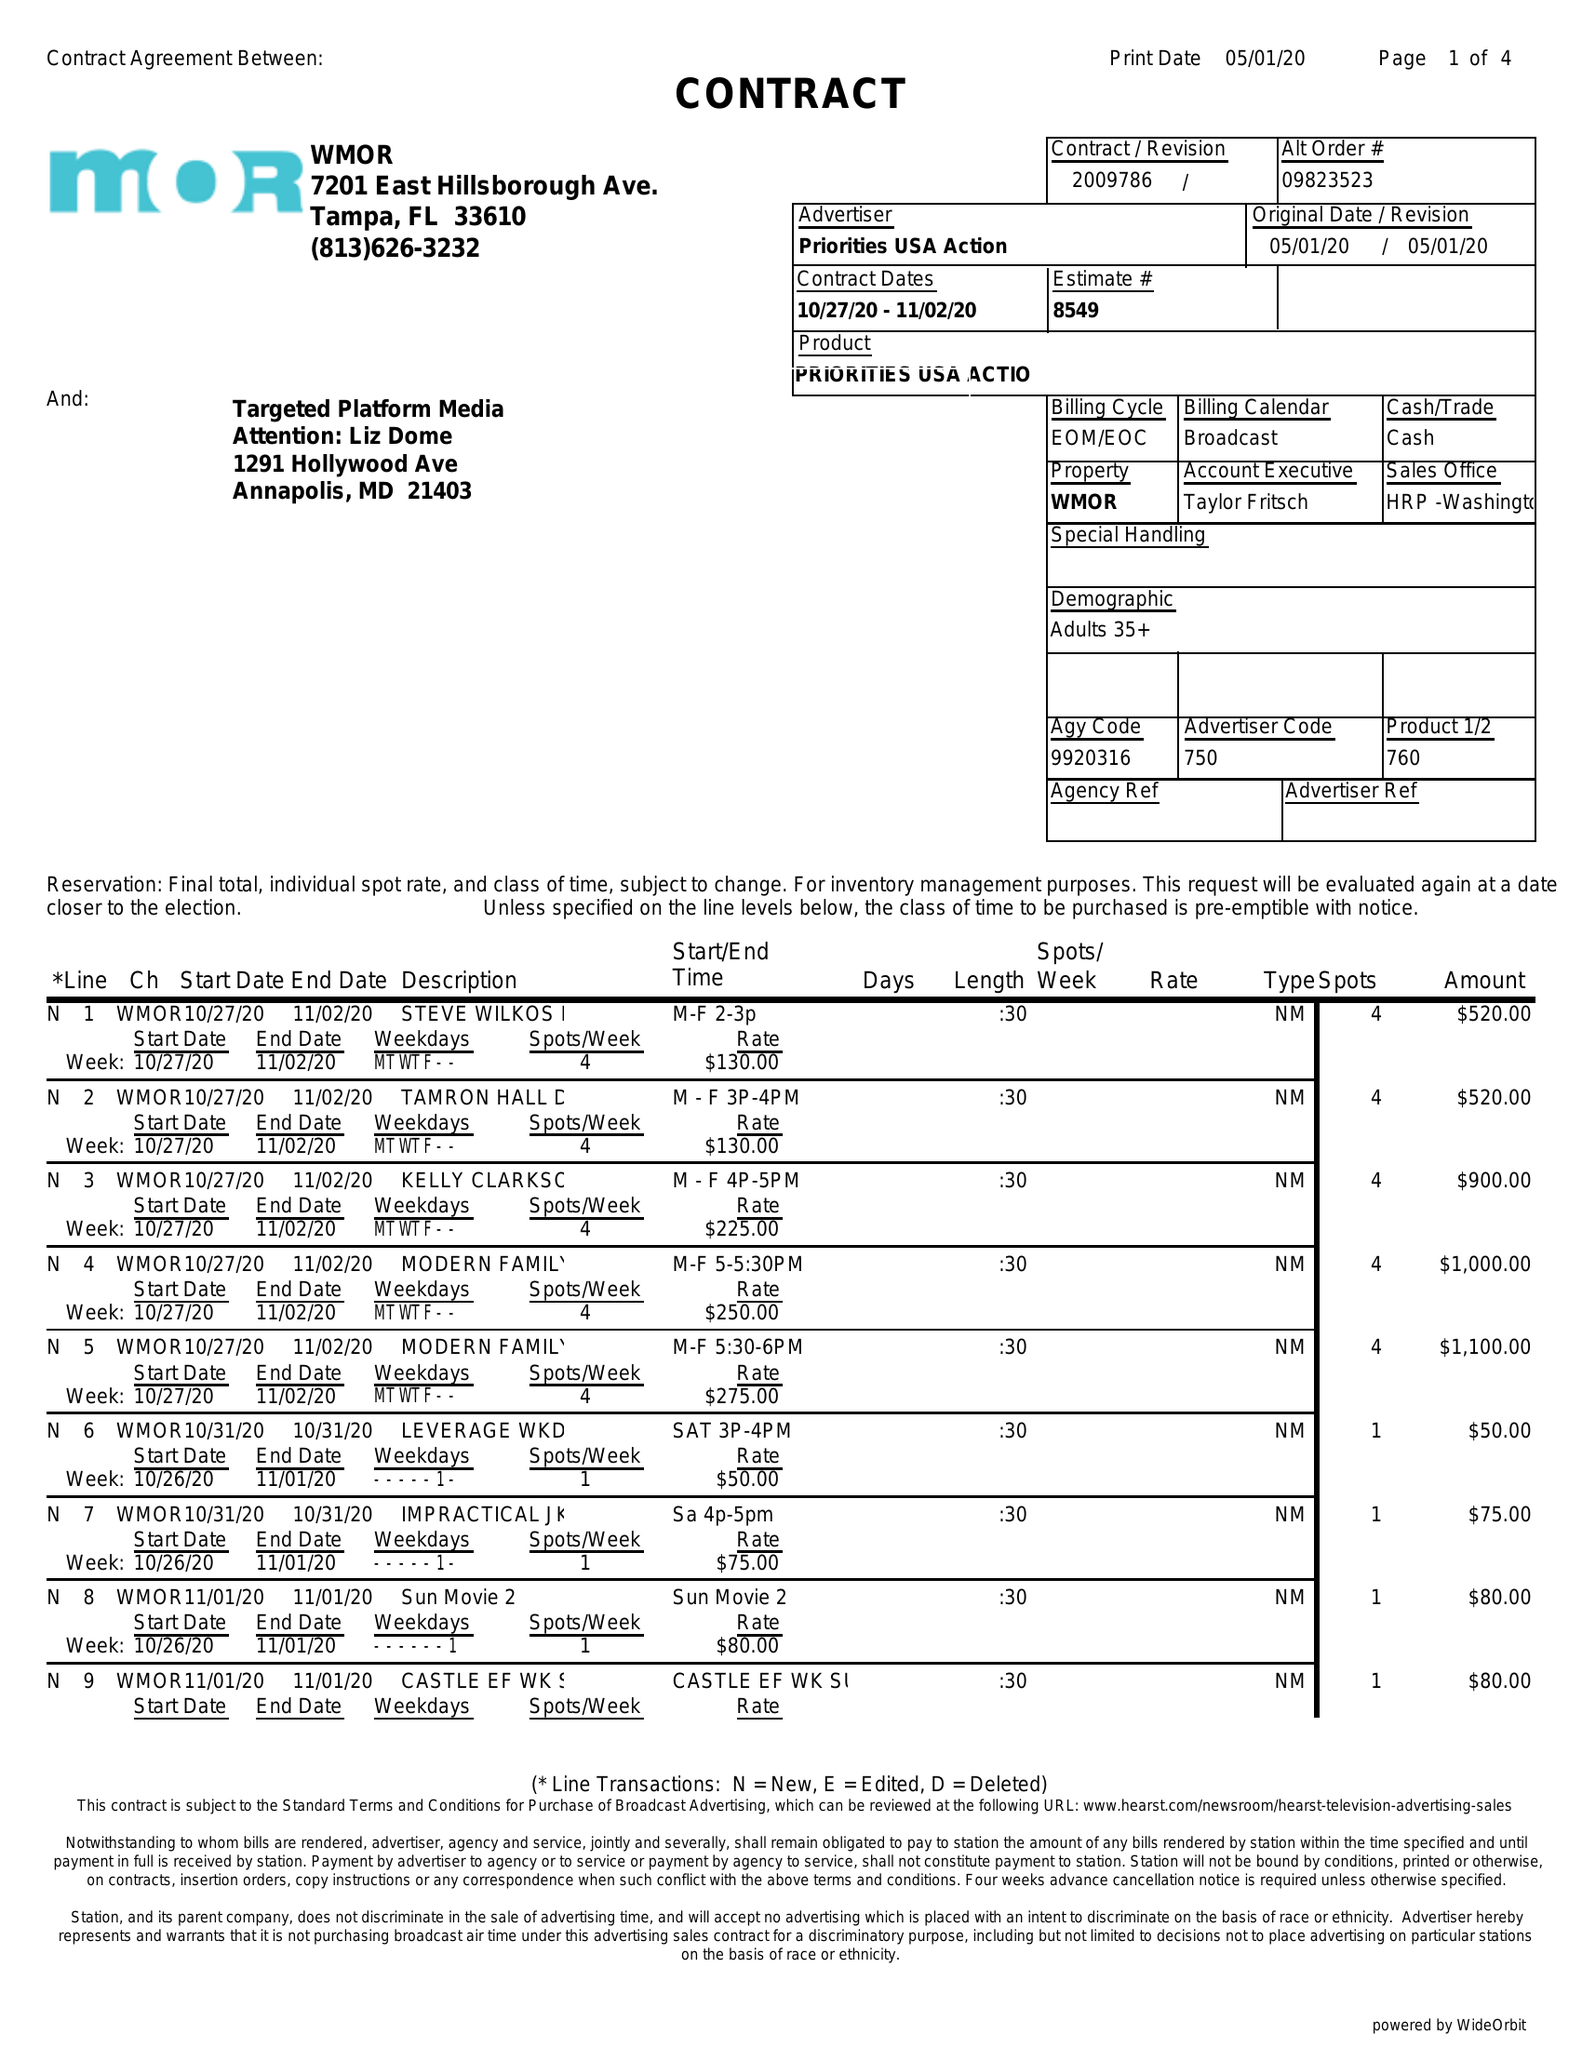What is the value for the flight_to?
Answer the question using a single word or phrase. 11/02/20 